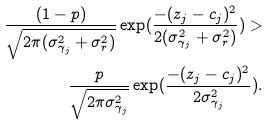Convert formula to latex. <formula><loc_0><loc_0><loc_500><loc_500>\frac { ( 1 - p ) } { \sqrt { 2 \pi ( \sigma ^ { 2 } _ { \gamma _ { j } } + \sigma ^ { 2 } _ { r } ) } } \exp ( \frac { - ( z _ { j } - c _ { j } ) ^ { 2 } } { 2 ( \sigma ^ { 2 } _ { \gamma _ { j } } + \sigma ^ { 2 } _ { r } ) } ) > \\ \frac { p } { \sqrt { 2 \pi \sigma ^ { 2 } _ { \gamma _ { j } } } } \exp ( \frac { - ( z _ { j } - c _ { j } ) ^ { 2 } } { 2 \sigma ^ { 2 } _ { \gamma _ { j } } } ) .</formula> 